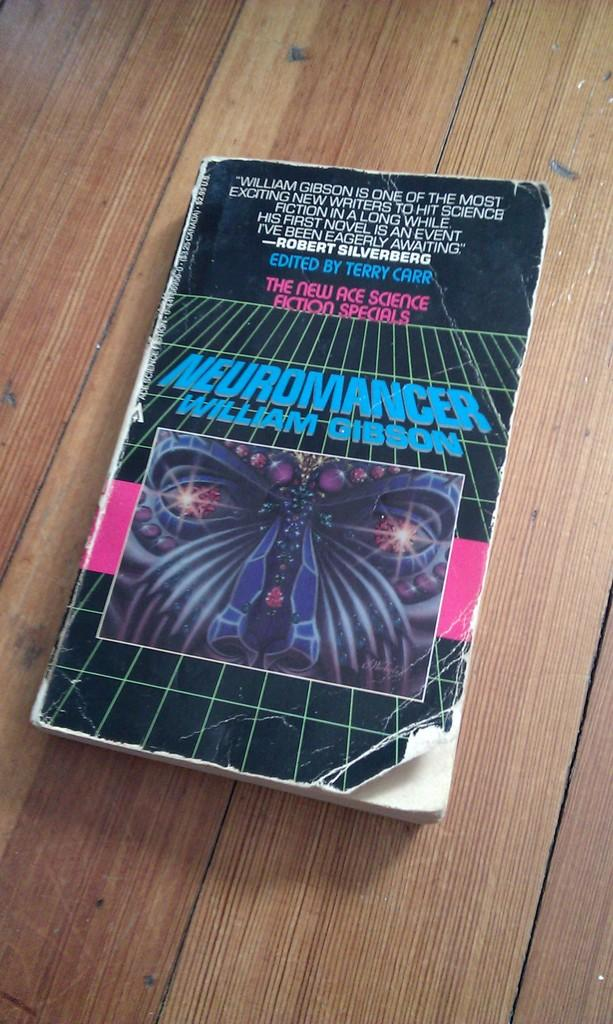<image>
Present a compact description of the photo's key features. A book by William Gibson is on a wood surface. 